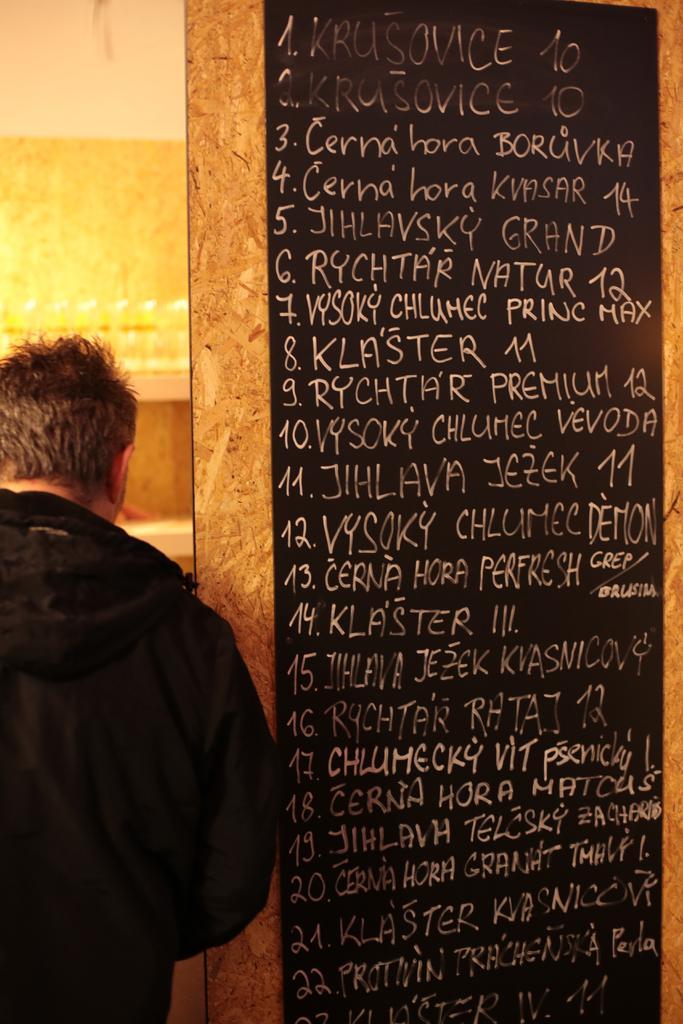Can you describe this image briefly? As we can see in the image there is a wall and a man wearing black color jacket. 